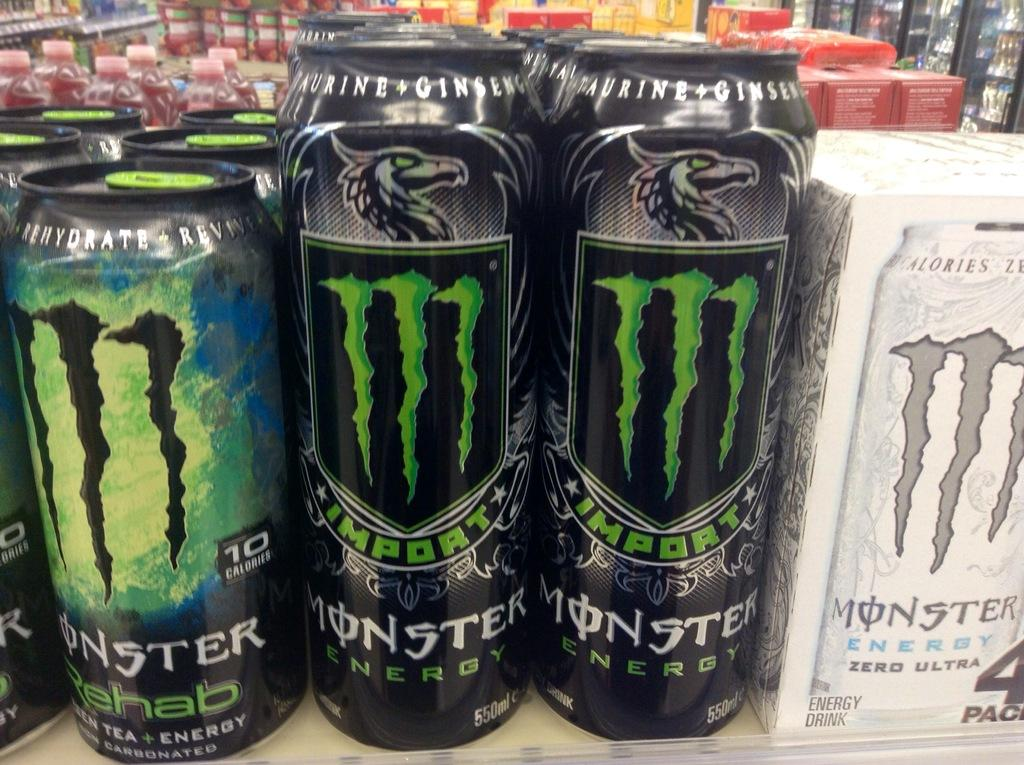<image>
Provide a brief description of the given image. Cans of Monster lined up next to each other with Monster Zero on the right 